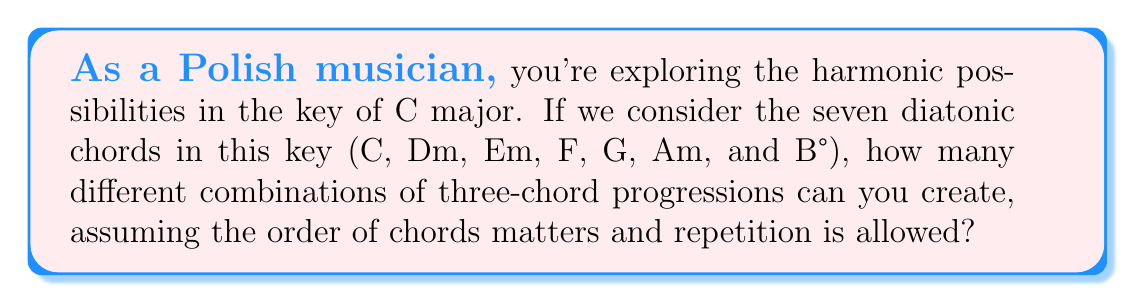Give your solution to this math problem. To solve this problem, we need to use the concept of permutations with repetition. Here's a step-by-step explanation:

1. We have 7 different chords to choose from (C, Dm, Em, F, G, Am, and B°).

2. We want to create a three-chord progression, which means we're selecting 3 chords.

3. The order of the chords matters (e.g., C-F-G is different from G-F-C).

4. Repetition is allowed (e.g., C-C-G is a valid progression).

5. This scenario fits the formula for permutations with repetition:

   $$ n^r $$

   Where:
   $n$ = number of options to choose from (in this case, 7 chords)
   $r$ = number of selections (in this case, 3 chords in the progression)

6. Plugging in our values:

   $$ 7^3 = 7 \times 7 \times 7 = 343 $$

Therefore, there are 343 possible three-chord progressions in the key of C major, given these conditions.
Answer: 343 possible three-chord progressions 